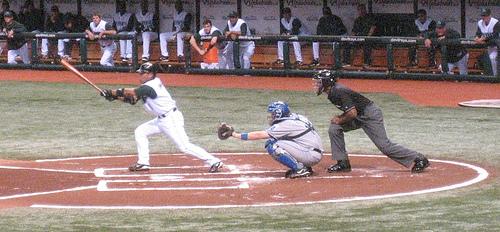How many people are shown?
Quick response, please. 19. Are all the people in the picture wearing white pants?
Answer briefly. No. What is the title of the person on the right?
Write a very short answer. Umpire. 